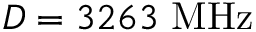<formula> <loc_0><loc_0><loc_500><loc_500>D = 3 2 6 3 M H z</formula> 